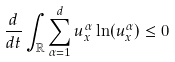<formula> <loc_0><loc_0><loc_500><loc_500>\frac { d } { d t } \int _ { \mathbb { R } } { \sum _ { \alpha = 1 } ^ { d } { u ^ { \alpha } _ { x } \ln ( u ^ { \alpha } _ { x } ) } } \leq 0</formula> 